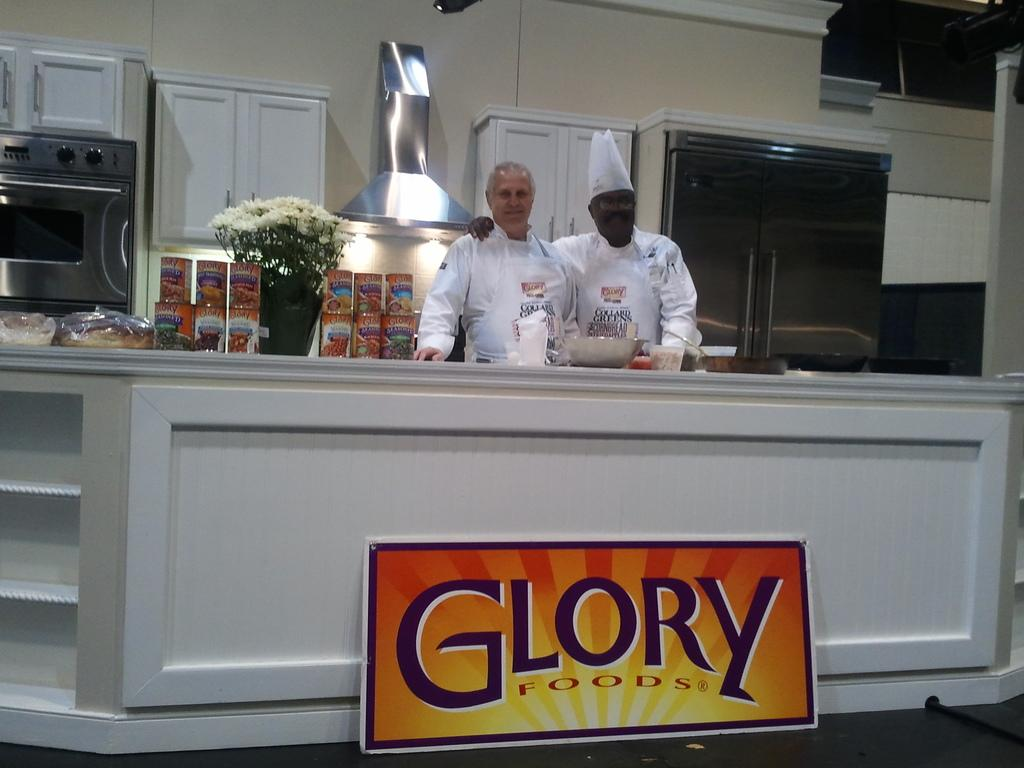<image>
Relay a brief, clear account of the picture shown. Two chefs are in the kitchen behind a Glory Foods sign. 